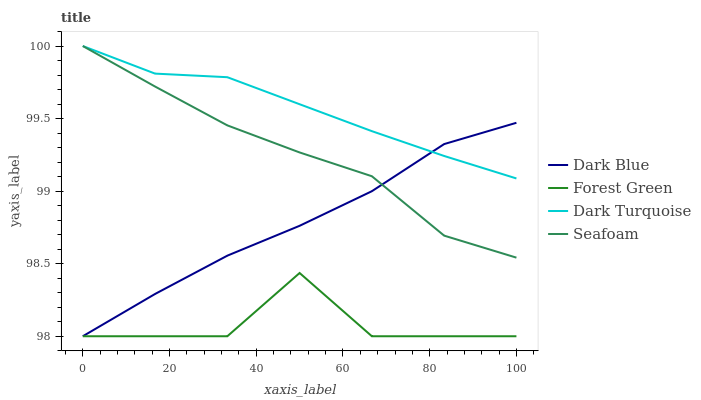Does Seafoam have the minimum area under the curve?
Answer yes or no. No. Does Seafoam have the maximum area under the curve?
Answer yes or no. No. Is Seafoam the smoothest?
Answer yes or no. No. Is Seafoam the roughest?
Answer yes or no. No. Does Seafoam have the lowest value?
Answer yes or no. No. Does Forest Green have the highest value?
Answer yes or no. No. Is Forest Green less than Seafoam?
Answer yes or no. Yes. Is Seafoam greater than Forest Green?
Answer yes or no. Yes. Does Forest Green intersect Seafoam?
Answer yes or no. No. 